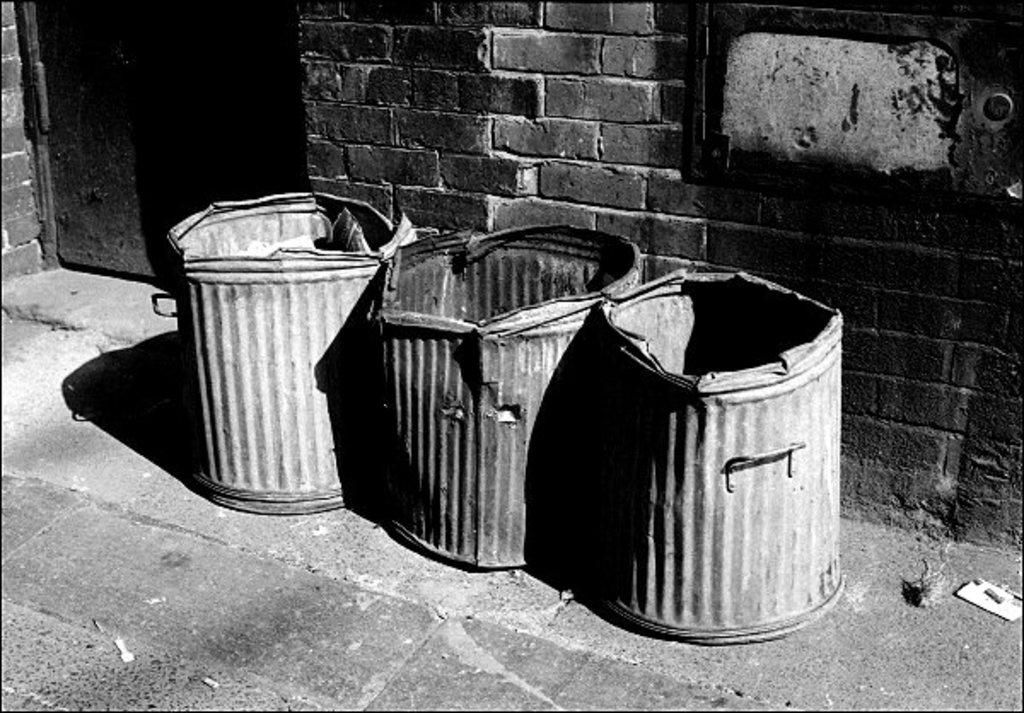Where was the image taken? The image was clicked outside. What can be seen in the foreground of the image? Containers are placed on the ground in the foreground. What is visible in the background of the image? There is a door and a brick wall in the background of the image. What type of amusement can be seen during the rainstorm in the image? There is no rainstorm or amusement present in the image. How many zebras are visible in the image? There are no zebras visible in the image. 